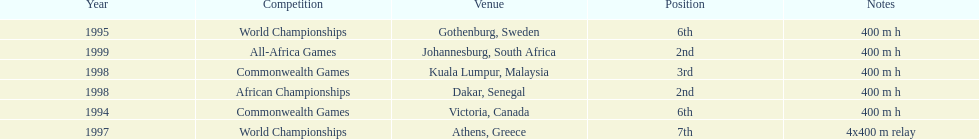What venue came before gothenburg, sweden? Victoria, Canada. 